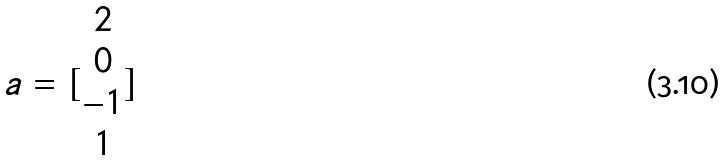<formula> <loc_0><loc_0><loc_500><loc_500>a = [ \begin{matrix} 2 \\ 0 \\ - 1 \\ 1 \end{matrix} ]</formula> 